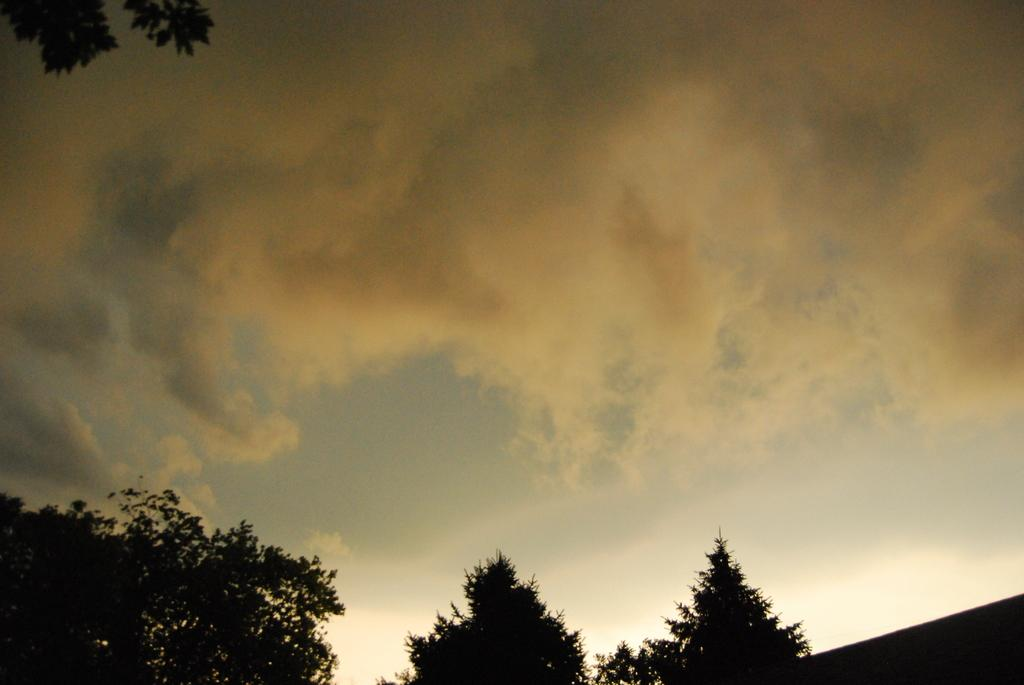What type of vegetation can be seen in the image? There are trees in the image. How would you describe the color of the sky in the image? The sky is a combination of cream, black, and white colors. What type of trousers is the robin wearing in the image? There is no robin or trousers present in the image. 